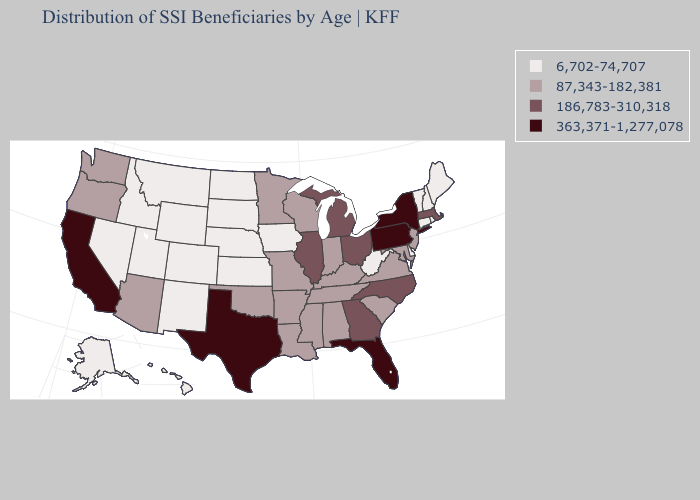What is the value of Delaware?
Write a very short answer. 6,702-74,707. What is the highest value in the South ?
Short answer required. 363,371-1,277,078. Among the states that border New Mexico , which have the highest value?
Be succinct. Texas. What is the highest value in the USA?
Write a very short answer. 363,371-1,277,078. Among the states that border Iowa , which have the lowest value?
Give a very brief answer. Nebraska, South Dakota. What is the value of South Carolina?
Give a very brief answer. 87,343-182,381. Does New Jersey have the lowest value in the USA?
Short answer required. No. Does Ohio have the lowest value in the USA?
Answer briefly. No. What is the lowest value in the USA?
Write a very short answer. 6,702-74,707. What is the lowest value in states that border Arizona?
Answer briefly. 6,702-74,707. Name the states that have a value in the range 363,371-1,277,078?
Short answer required. California, Florida, New York, Pennsylvania, Texas. Does Alabama have the same value as North Dakota?
Concise answer only. No. What is the highest value in the MidWest ?
Quick response, please. 186,783-310,318. Name the states that have a value in the range 186,783-310,318?
Quick response, please. Georgia, Illinois, Massachusetts, Michigan, North Carolina, Ohio. What is the lowest value in the West?
Concise answer only. 6,702-74,707. 